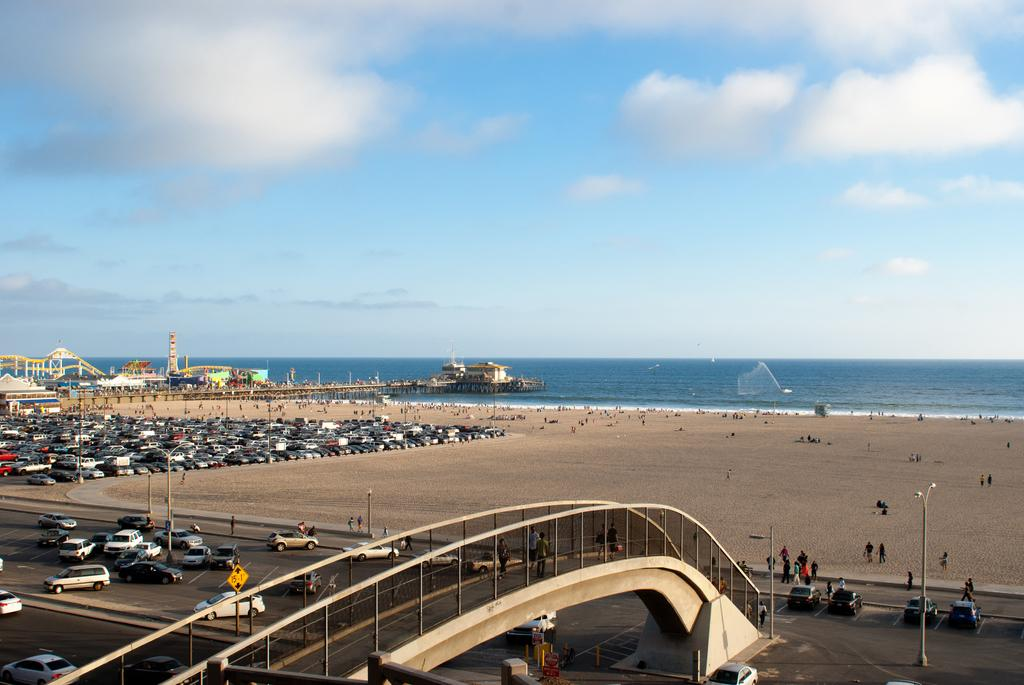What types of vehicles can be seen in the image? There are vehicles in the image, but the specific types are not mentioned. What are the people on the ground doing in the image? The actions of the people on the ground are not mentioned, but they are present in the image. What is the purpose of the signboard in the image? The purpose of the signboard is not mentioned, but it is present in the image. What are the poles used for in the image? The purpose of the poles is not mentioned, but they are present in the image. What is the bridge connecting in the image? The bridge is connecting two points, but the specific locations are not mentioned. What is the water visible in the image? The water is visible in the image, but its specific location or purpose is not mentioned. What types of objects can be seen in the image? The types of objects present in the image are not mentioned. What is visible in the background of the image? The sky is visible in the background of the image, and there are clouds in the sky. How does the plastic exchange hands in the image? There is no plastic present in the image, and therefore no such exchange can be observed. 